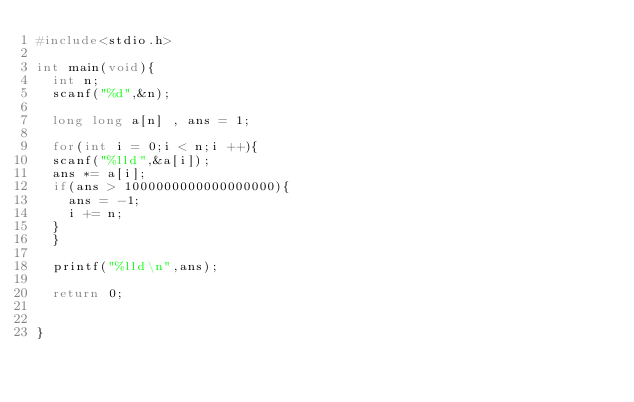Convert code to text. <code><loc_0><loc_0><loc_500><loc_500><_C_>#include<stdio.h>

int main(void){
  int n;
  scanf("%d",&n);

  long long a[n] , ans = 1;

  for(int i = 0;i < n;i ++){
  scanf("%lld",&a[i]);
  ans *= a[i];
  if(ans > 1000000000000000000){
    ans = -1;
    i += n;
  }
  }

  printf("%lld\n",ans);

  return 0;


}
</code> 